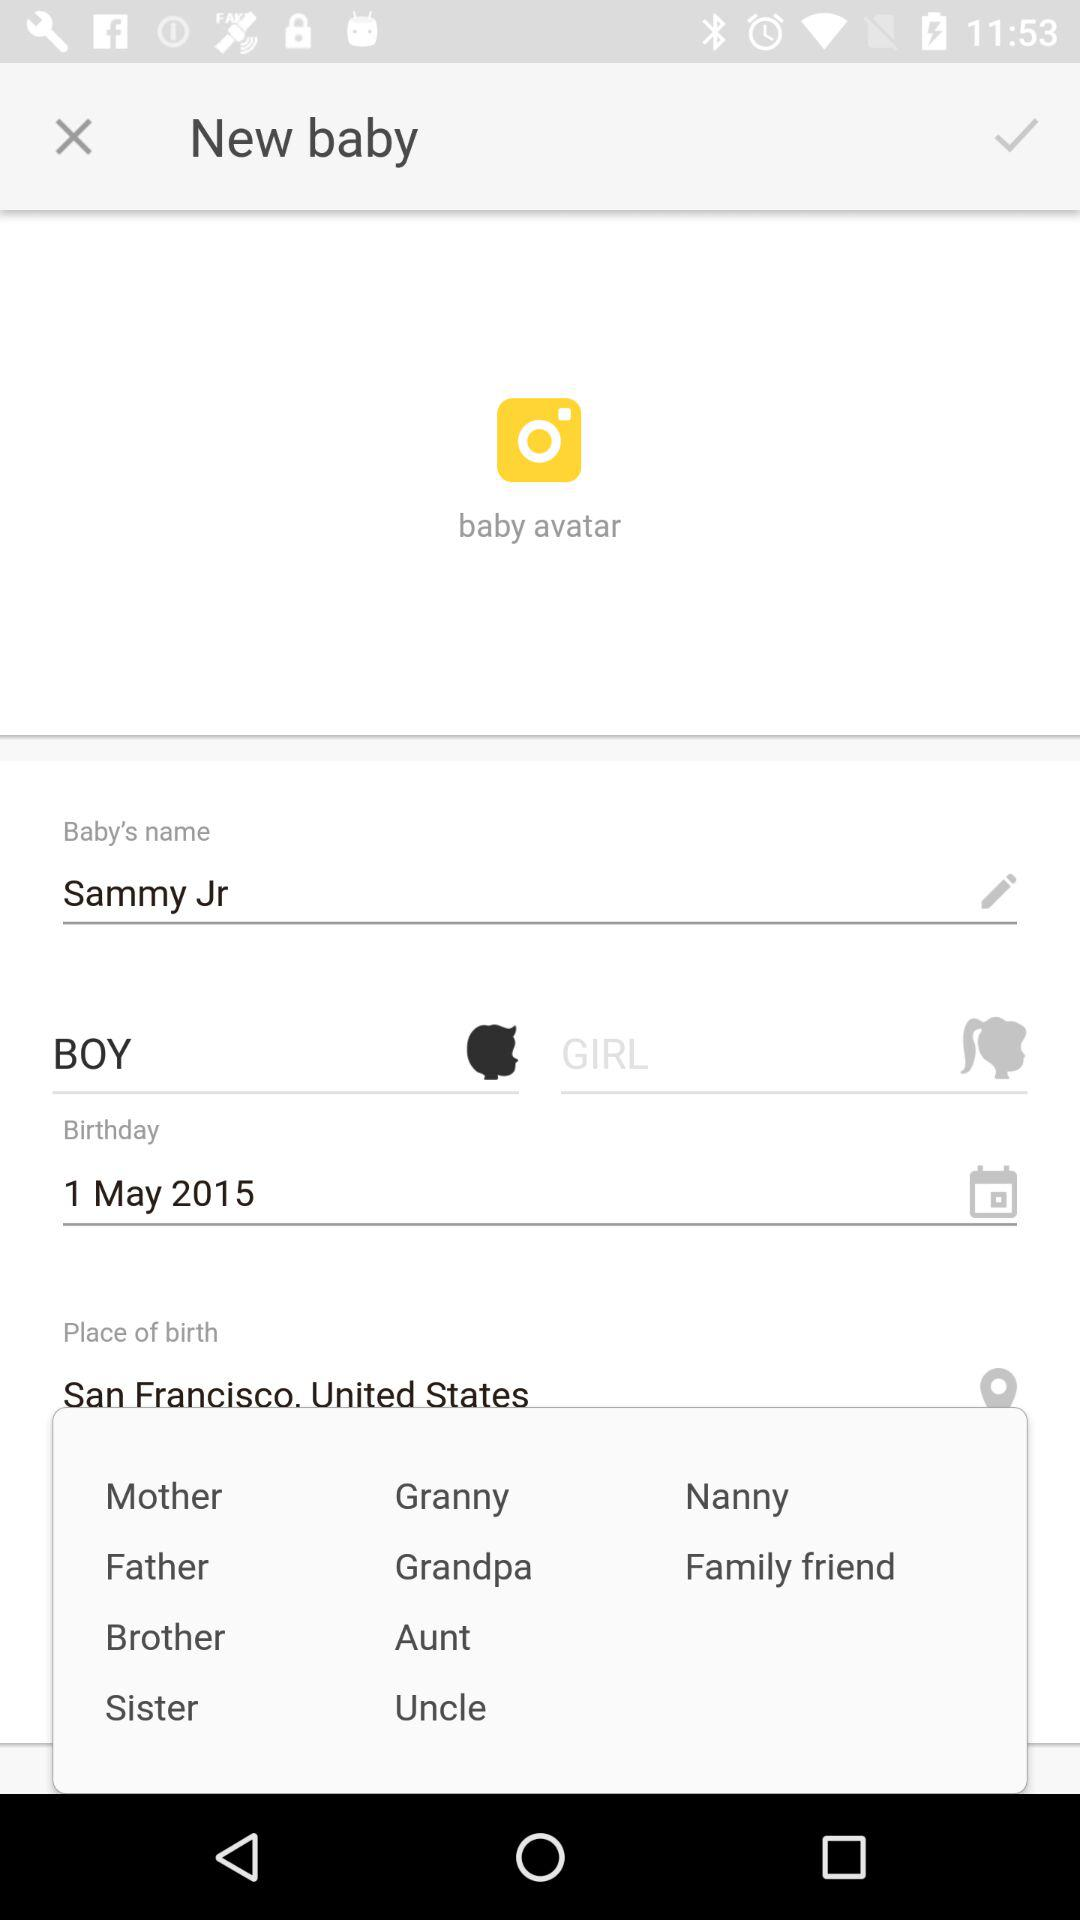What is the baby's name? The baby's name is Sammy Jr. 